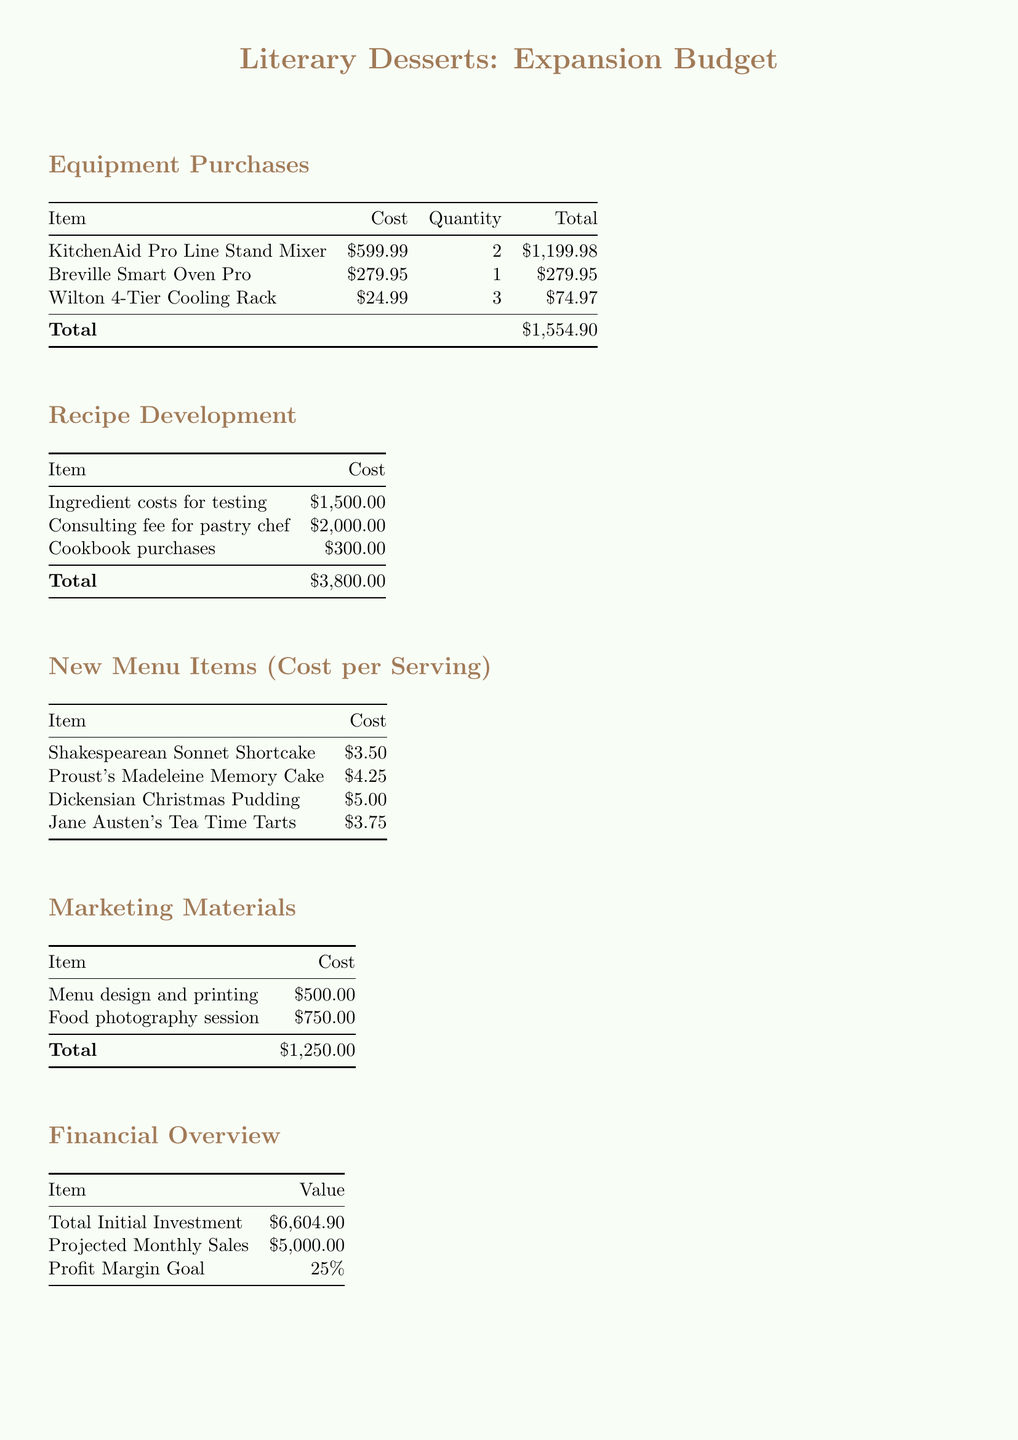What is the total cost for equipment purchases? The total cost for equipment purchases is listed in the table under the Equipment Purchases section, which amounts to $1,554.90.
Answer: $1,554.90 What are the ingredient costs for testing? The document specifies the ingredient costs for testing under Recipe Development, which is $1,500.00.
Answer: $1,500.00 What is the projected monthly sales figure? The projected monthly sales figure is mentioned in the Financial Overview section as $5,000.00.
Answer: $5,000.00 How many KitchenAid Pro Line Stand Mixers are being purchased? The Equipment Purchases table states that 2 KitchenAid Pro Line Stand Mixers are being purchased.
Answer: 2 What is the total cost for marketing materials? The total cost for marketing materials is provided in its section, which comes to $1,250.00.
Answer: $1,250.00 What is the profit margin goal? The profit margin goal is stated in the Financial Overview as 25%.
Answer: 25% When is the new menu launch date? The new menu launch date is specified in the Timeline section as October 15, 2023.
Answer: October 15, 2023 What is the total initial investment? The total initial investment is highlighted in the Financial Overview and is $6,604.90.
Answer: $6,604.90 What is the cost per serving for Proust's Madeleine Memory Cake? The cost per serving for Proust's Madeleine Memory Cake is listed in the New Menu Items section as $4.25.
Answer: $4.25 